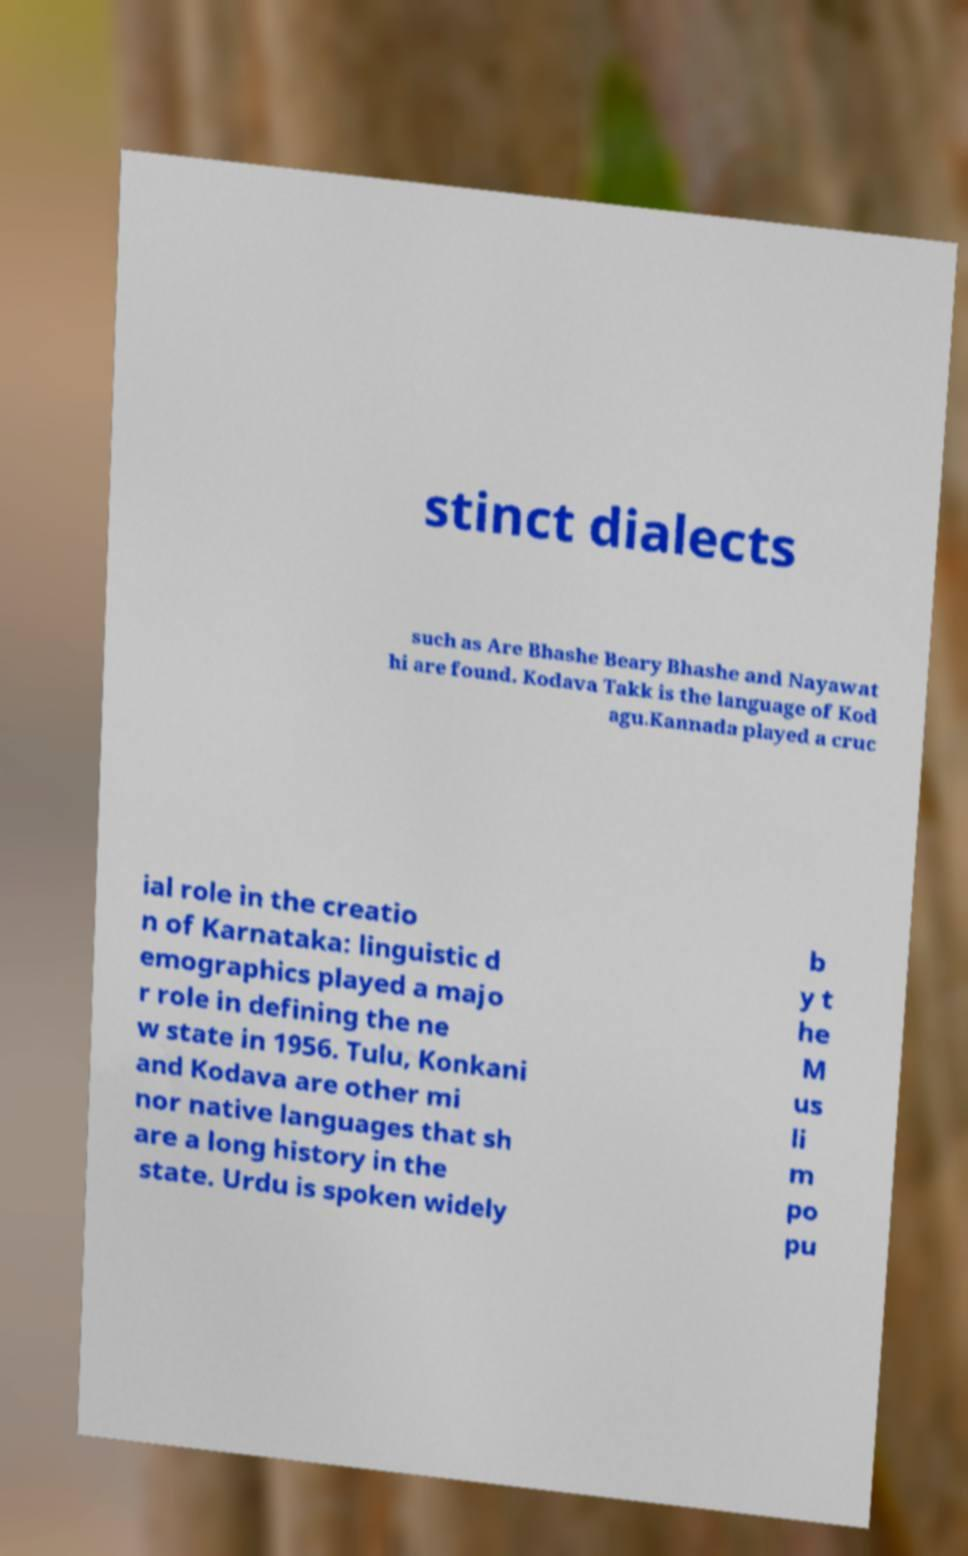Please read and relay the text visible in this image. What does it say? stinct dialects such as Are Bhashe Beary Bhashe and Nayawat hi are found. Kodava Takk is the language of Kod agu.Kannada played a cruc ial role in the creatio n of Karnataka: linguistic d emographics played a majo r role in defining the ne w state in 1956. Tulu, Konkani and Kodava are other mi nor native languages that sh are a long history in the state. Urdu is spoken widely b y t he M us li m po pu 